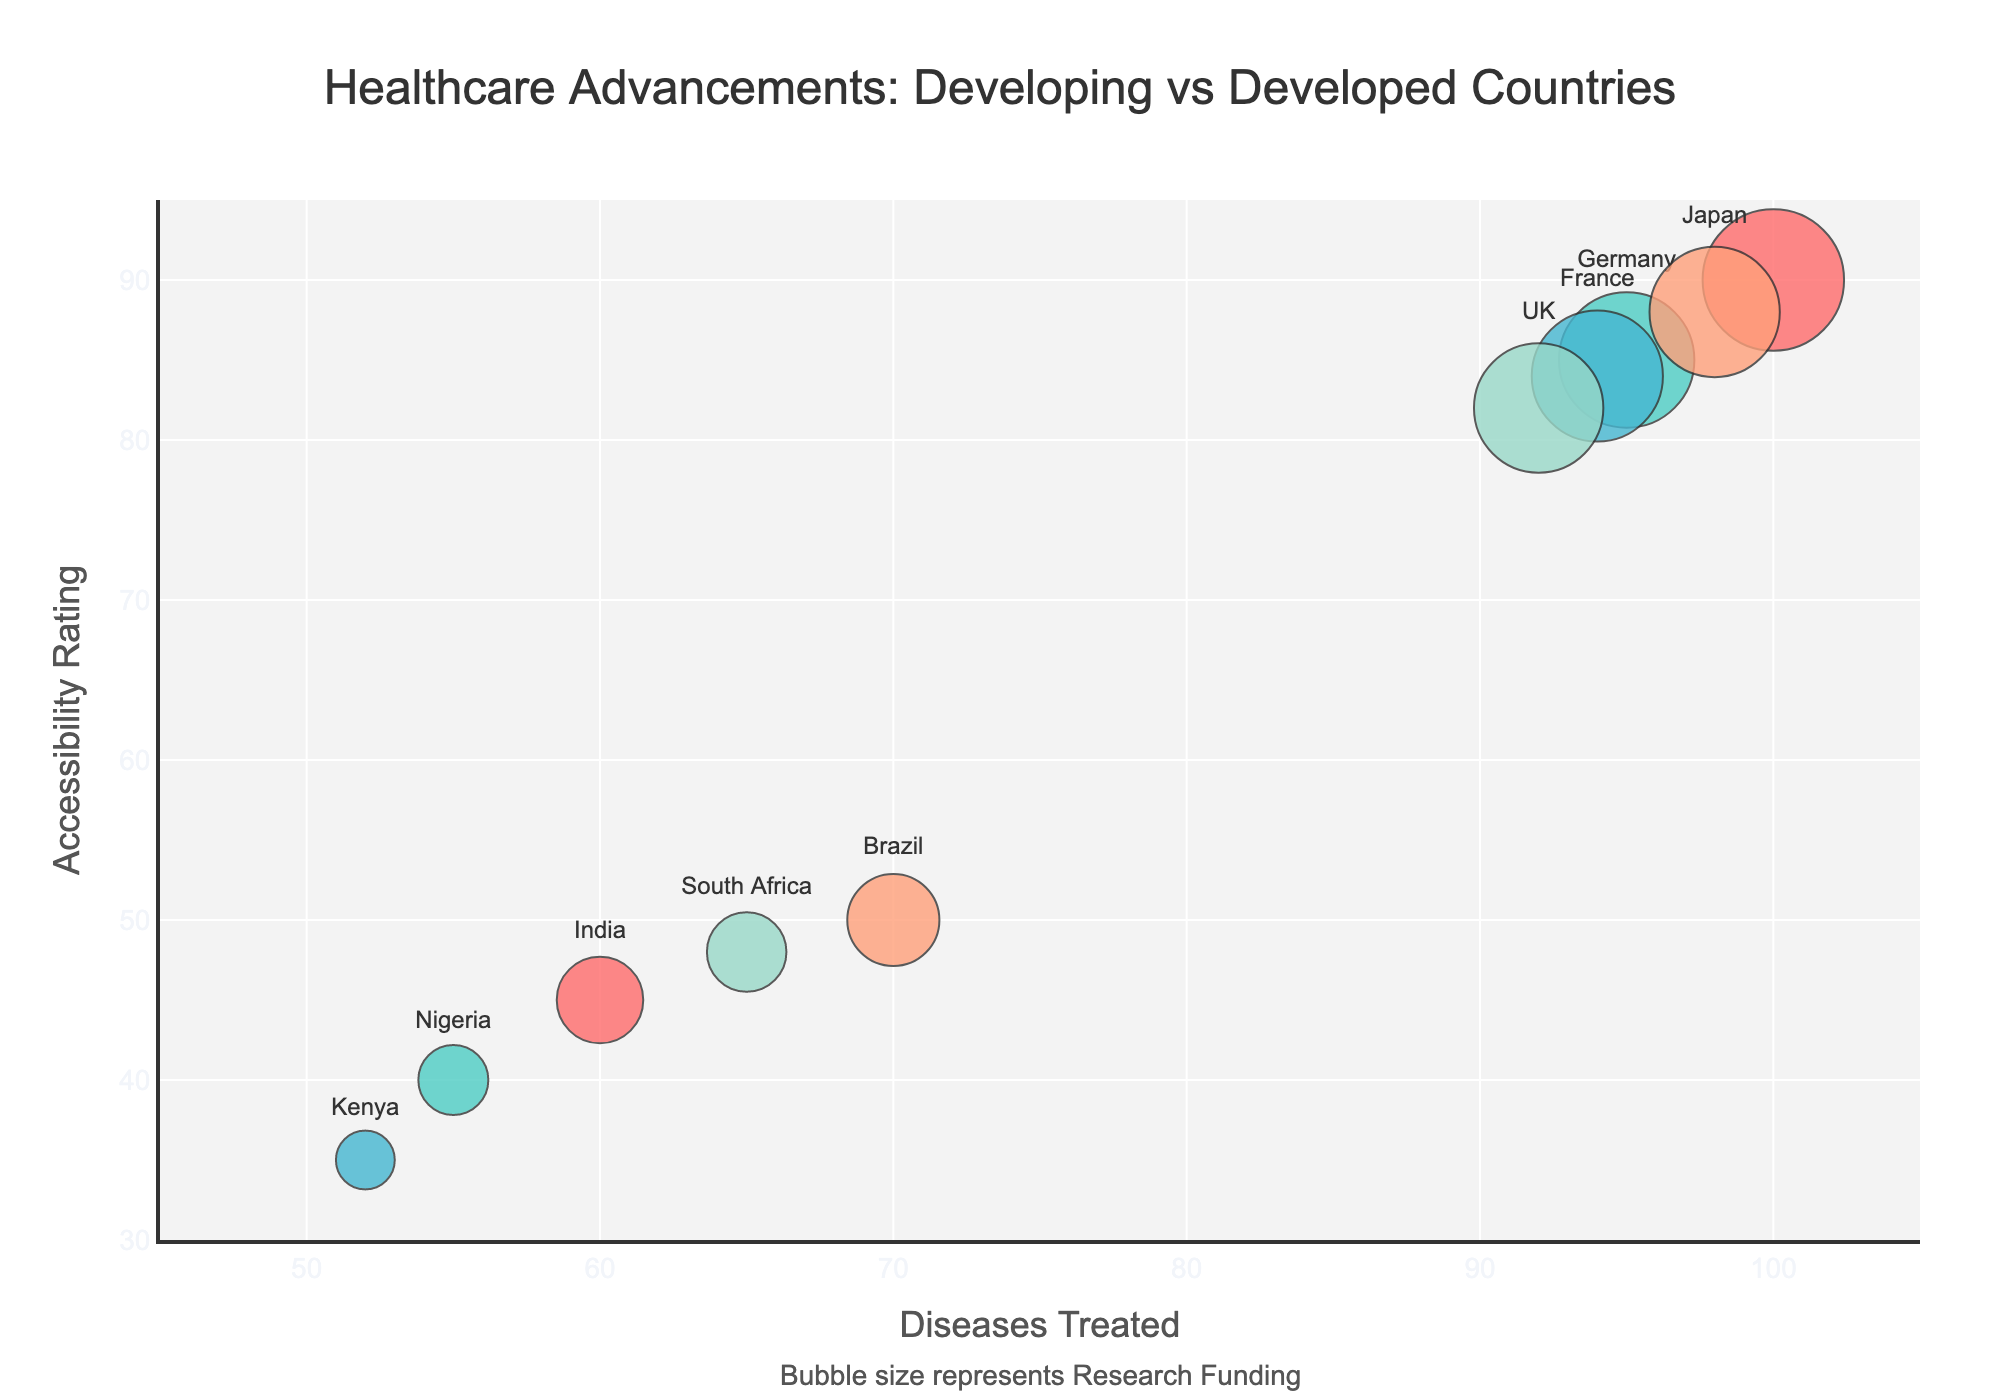How many countries are plotted in the figure? By examining the number of distinct bubbles in the plot, we can count the total number of countries represented.
Answer: 10 What is the title of the figure? The title is located at the top center of the figure.
Answer: Healthcare Advancements: Developing vs Developed Countries Which countries have Accessibility Ratings less than 50? Bubbles positioned below the y-axis value of 50 represent countries with Accessibility Ratings less than 50. Identify these countries based on the bubble labels.
Answer: India, Nigeria, Kenya, Brazil, South Africa Which country has the highest number of Diseases Treated? Find the bubble farthest to the right on the x-axis, which represents the country with the highest value for Diseases Treated.
Answer: USA How much Research Funding is available for the country with the lowest Accessibility Rating? Identify the country with the lowest y-axis value (Accessibility Rating), then look at the bubble size (which correlates Research Funding) or hover over the bubble to obtain the exact Research Funding value.
Answer: Kenya, $150,000,000 Compare the Research Funding available and Accessibility Rating between Germany and Japan. Look at the size of the bubbles for both countries (indicating Research Funding) and their positions on the y-axis (indicating Accessibility Rating).
Answer: Germany: $4,200,000,000, Accessibility: 85; Japan: $3,600,000,000, Accessibility: 88 Which country has the smallest bubble size, indicating the least Research Funding? The smallest bubble (in terms of size) represents the country with the least Research Funding. Hover over the bubble to confirm the country name.
Answer: Kenya What is the average Accessibility Rating for developing countries (India, Nigeria, Kenya, Brazil, South Africa)? Sum the Accessibility Ratings of these five countries and divide by 5.
Answer: (45 + 40 + 35 + 50 + 48) / 5 = 43.6 Between the USA and India, which country has a higher Diseases Treated and by how much? Find the x-axis values for both countries and subtract the value for India from the value for the USA.
Answer: USA has 40 more Diseases Treated than India (100 - 60) Describe the relationship between Research Funding and Accessibility Rating in developed countries (USA, Germany, France, Japan, UK). Examine the bubble sizes (Research Funding) and y-axis positions (Accessibility Rating) for these countries, and note any patterns or trends.
Answer: Generally, developed countries tend to have high Research Funding and Accessibility Ratings 